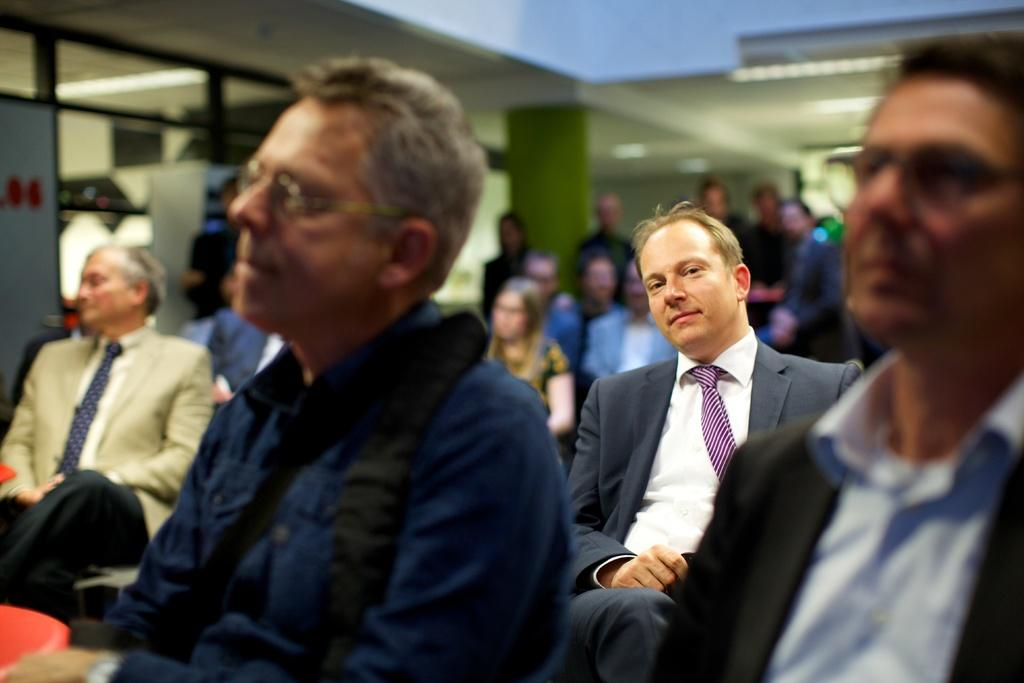What are the people in the image doing? There is a group of people sitting and a group of people standing in the image. What can be seen in the background of the image? There are glass windows and a pillar in the background of the image. What type of amusement can be seen in the image? There is no amusement present in the image; it features a group of people sitting and standing with a background of glass windows and a pillar. How many leaves are on the clover in the image? There is no clover present in the image. 